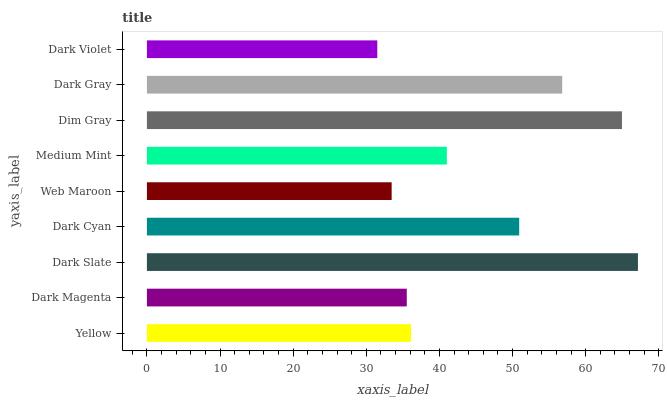Is Dark Violet the minimum?
Answer yes or no. Yes. Is Dark Slate the maximum?
Answer yes or no. Yes. Is Dark Magenta the minimum?
Answer yes or no. No. Is Dark Magenta the maximum?
Answer yes or no. No. Is Yellow greater than Dark Magenta?
Answer yes or no. Yes. Is Dark Magenta less than Yellow?
Answer yes or no. Yes. Is Dark Magenta greater than Yellow?
Answer yes or no. No. Is Yellow less than Dark Magenta?
Answer yes or no. No. Is Medium Mint the high median?
Answer yes or no. Yes. Is Medium Mint the low median?
Answer yes or no. Yes. Is Dim Gray the high median?
Answer yes or no. No. Is Web Maroon the low median?
Answer yes or no. No. 